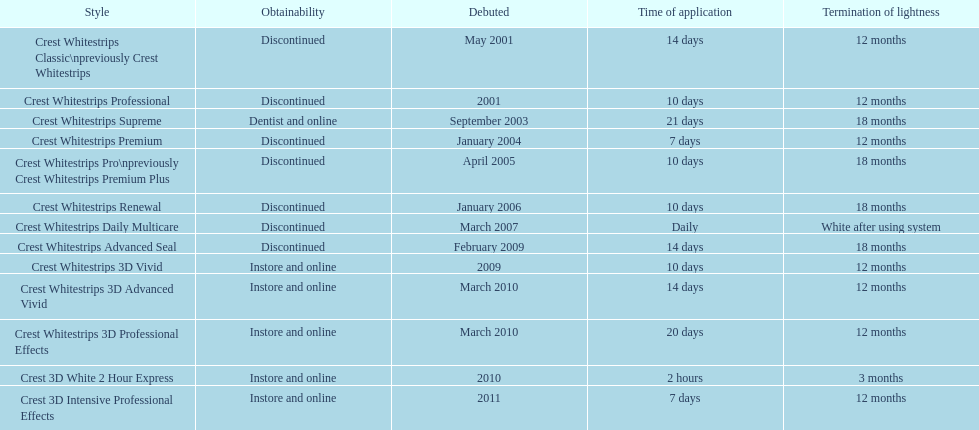How many products have been discontinued? 7. 